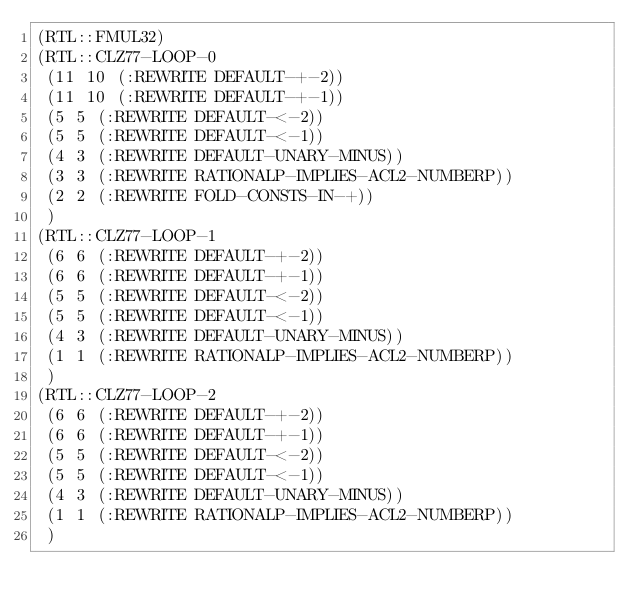<code> <loc_0><loc_0><loc_500><loc_500><_Lisp_>(RTL::FMUL32)
(RTL::CLZ77-LOOP-0
 (11 10 (:REWRITE DEFAULT-+-2))
 (11 10 (:REWRITE DEFAULT-+-1))
 (5 5 (:REWRITE DEFAULT-<-2))
 (5 5 (:REWRITE DEFAULT-<-1))
 (4 3 (:REWRITE DEFAULT-UNARY-MINUS))
 (3 3 (:REWRITE RATIONALP-IMPLIES-ACL2-NUMBERP))
 (2 2 (:REWRITE FOLD-CONSTS-IN-+))
 )
(RTL::CLZ77-LOOP-1
 (6 6 (:REWRITE DEFAULT-+-2))
 (6 6 (:REWRITE DEFAULT-+-1))
 (5 5 (:REWRITE DEFAULT-<-2))
 (5 5 (:REWRITE DEFAULT-<-1))
 (4 3 (:REWRITE DEFAULT-UNARY-MINUS))
 (1 1 (:REWRITE RATIONALP-IMPLIES-ACL2-NUMBERP))
 )
(RTL::CLZ77-LOOP-2
 (6 6 (:REWRITE DEFAULT-+-2))
 (6 6 (:REWRITE DEFAULT-+-1))
 (5 5 (:REWRITE DEFAULT-<-2))
 (5 5 (:REWRITE DEFAULT-<-1))
 (4 3 (:REWRITE DEFAULT-UNARY-MINUS))
 (1 1 (:REWRITE RATIONALP-IMPLIES-ACL2-NUMBERP))
 )</code> 